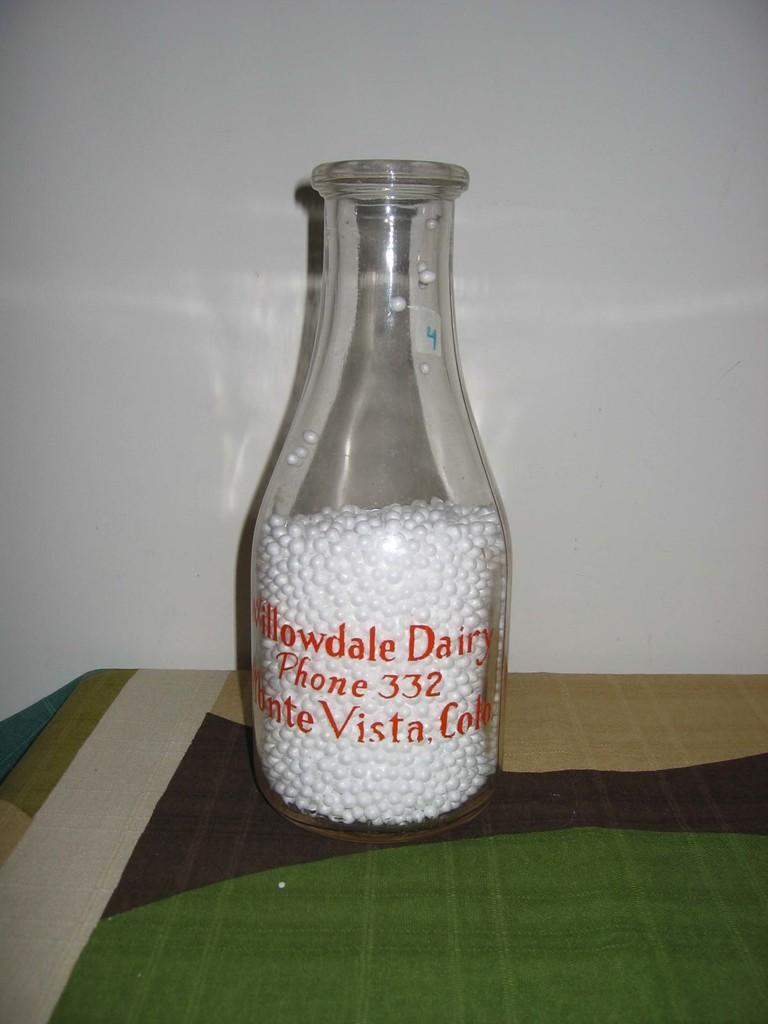<image>
Write a terse but informative summary of the picture. The bottle with the white balls inside is from Willowdale Dairy in Monte Vista, Colorado. 